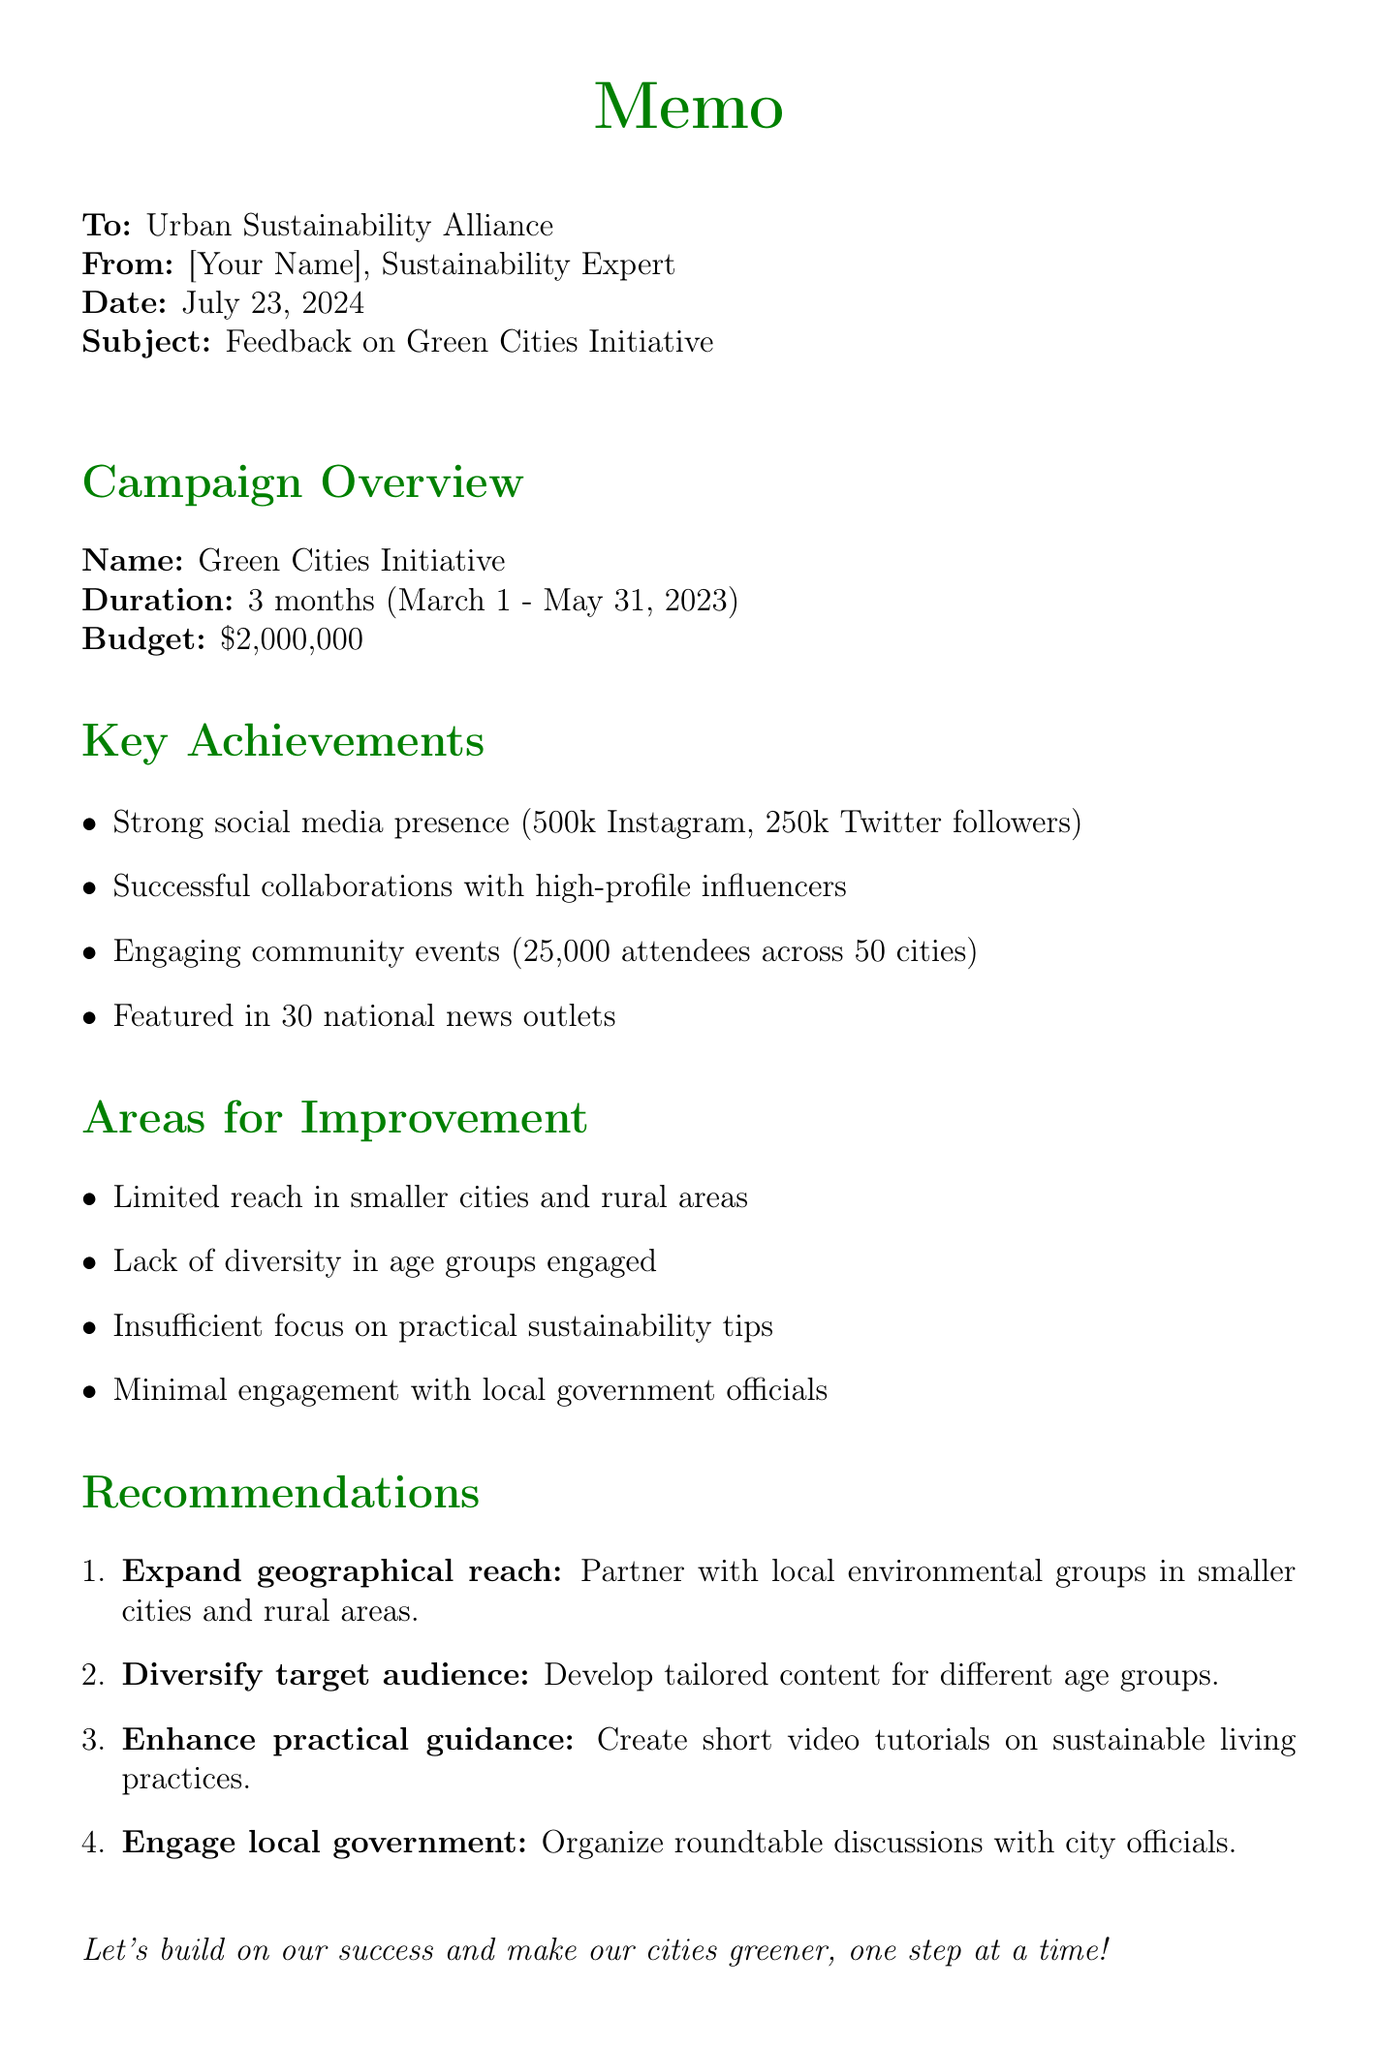What are the campaign objectives? The campaign objectives are listed in the document as a set of goals for the Green Cities Initiative.
Answer: Raise awareness about urban sustainability, Promote eco-friendly practices in cities, Encourage citizen participation in green initiatives Who were the influencers involved in the campaign? The feedback section highlights the successful collaboration with specific influencers, which showcases their involvement.
Answer: Emma Watson and Leonardo DiCaprio What was the duration of the campaign? The duration is mentioned clearly in the campaign overview section of the memo.
Answer: 3 months (March 1 - May 31, 2023) What is the total budget allocated for the campaign? The budget is summarized in the campaign overview section, indicating the total amount set aside for the initiative.
Answer: $2,000,000 Which area for improvement involves local government? The areas for improvement section identifies specific challenges related to engagement, highlighting the local government's role.
Answer: Minimal engagement with local government officials What is one of the key achievements in social media engagement? The key achievements section mentions specific metrics related to social media platforms.
Answer: 500,000 followers on Instagram What is a recommended action for engaging a wider audience? The recommendations section provides specific actions aimed at improving outreach and engagement with diverse demographics.
Answer: Develop tailored content and events for different age groups How many attendees participated in the community events? The event participation metric is documented in the key achievements section of the memo.
Answer: 25,000 attendees across 50 cities 